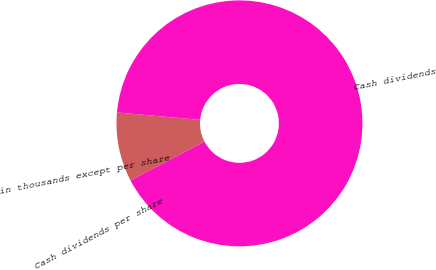Convert chart. <chart><loc_0><loc_0><loc_500><loc_500><pie_chart><fcel>in thousands except per share<fcel>Cash dividends<fcel>Cash dividends per share<nl><fcel>9.09%<fcel>90.91%<fcel>0.0%<nl></chart> 